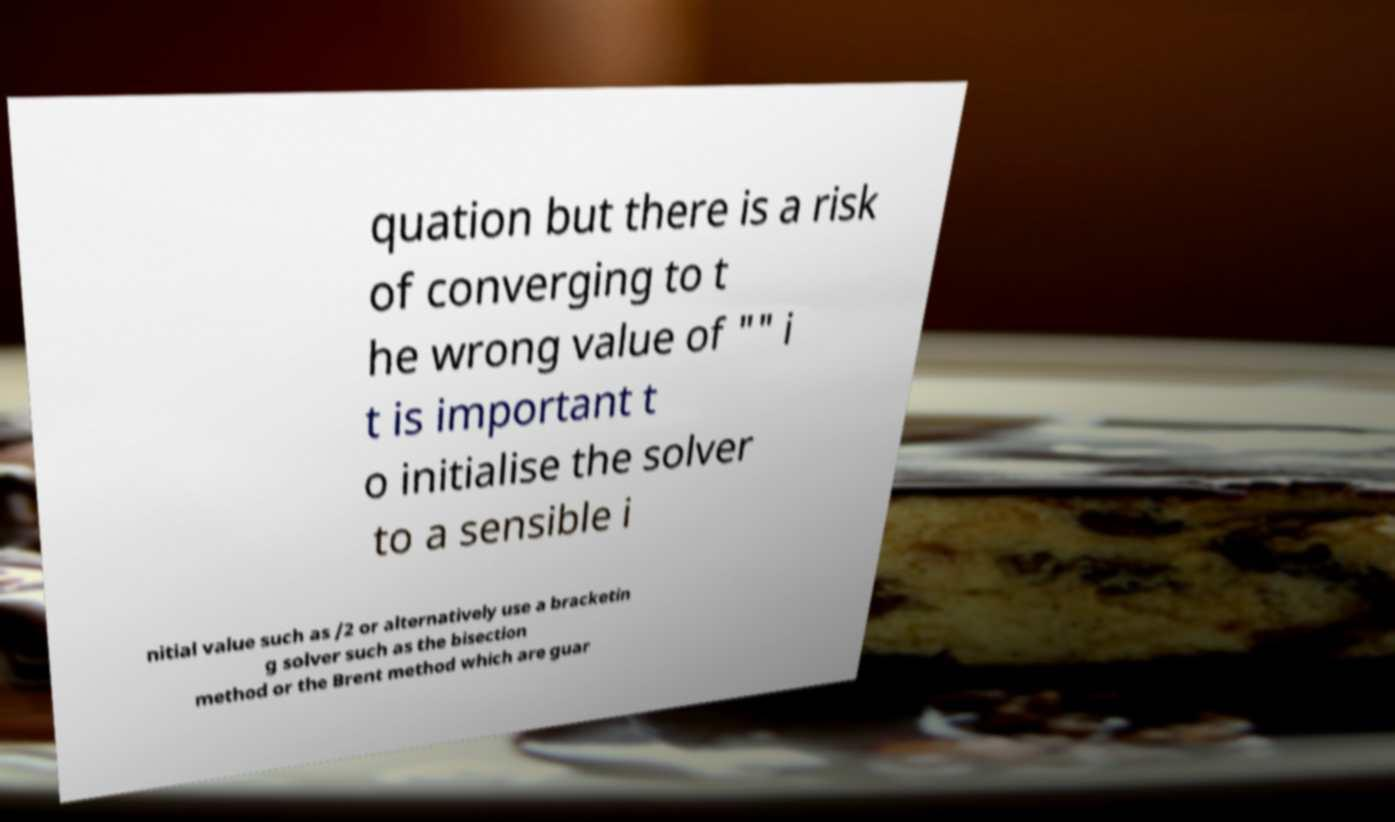What messages or text are displayed in this image? I need them in a readable, typed format. quation but there is a risk of converging to t he wrong value of "" i t is important t o initialise the solver to a sensible i nitial value such as /2 or alternatively use a bracketin g solver such as the bisection method or the Brent method which are guar 